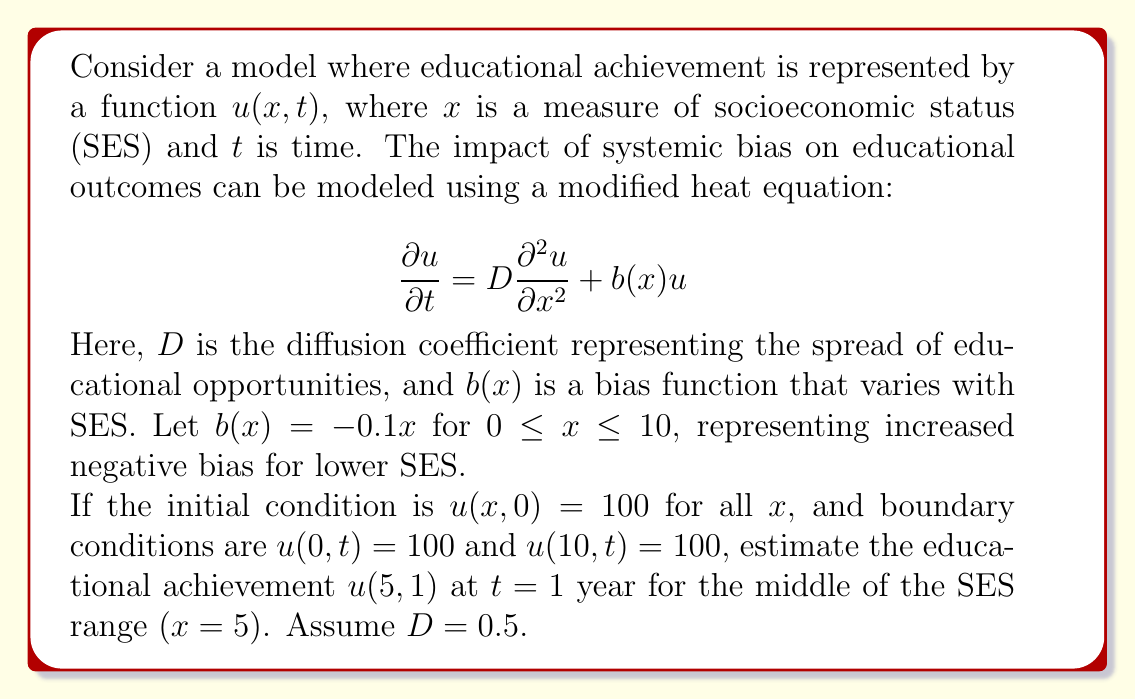What is the answer to this math problem? To solve this problem, we need to use numerical methods as an analytical solution is not readily available for this modified heat equation. We'll use the finite difference method to approximate the solution.

1) First, we discretize the space and time domains:
   Let $\Delta x = 0.5$ and $\Delta t = 0.01$
   This gives us 21 spatial points $(0, 0.5, 1, ..., 10)$ and 101 time points $(0, 0.01, 0.02, ..., 1)$

2) We use the following finite difference approximations:
   $$\frac{\partial u}{\partial t} \approx \frac{u_{i,j+1} - u_{i,j}}{\Delta t}$$
   $$\frac{\partial^2 u}{\partial x^2} \approx \frac{u_{i+1,j} - 2u_{i,j} + u_{i-1,j}}{(\Delta x)^2}$$

3) Substituting these into our PDE:
   $$\frac{u_{i,j+1} - u_{i,j}}{\Delta t} = D\frac{u_{i+1,j} - 2u_{i,j} + u_{i-1,j}}{(\Delta x)^2} + b(x_i)u_{i,j}$$

4) Rearranging to solve for $u_{i,j+1}$:
   $$u_{i,j+1} = u_{i,j} + D\frac{\Delta t}{(\Delta x)^2}(u_{i+1,j} - 2u_{i,j} + u_{i-1,j}) + \Delta t \cdot b(x_i)u_{i,j}$$

5) We implement this scheme in a programming language (e.g., Python) and iterate through all time steps.

6) At each step, we enforce the boundary conditions $u(0,t) = u(10,t) = 100$.

7) After running the simulation, we look at the value of $u$ at $x=5$ and $t=1$.

The numerical solution gives an approximate value of $u(5,1) \approx 93.2$.

This result shows that the systemic bias has reduced the educational achievement at the middle of the SES range from the initial value of 100 to approximately 93.2 after one year.
Answer: $u(5,1) \approx 93.2$ 